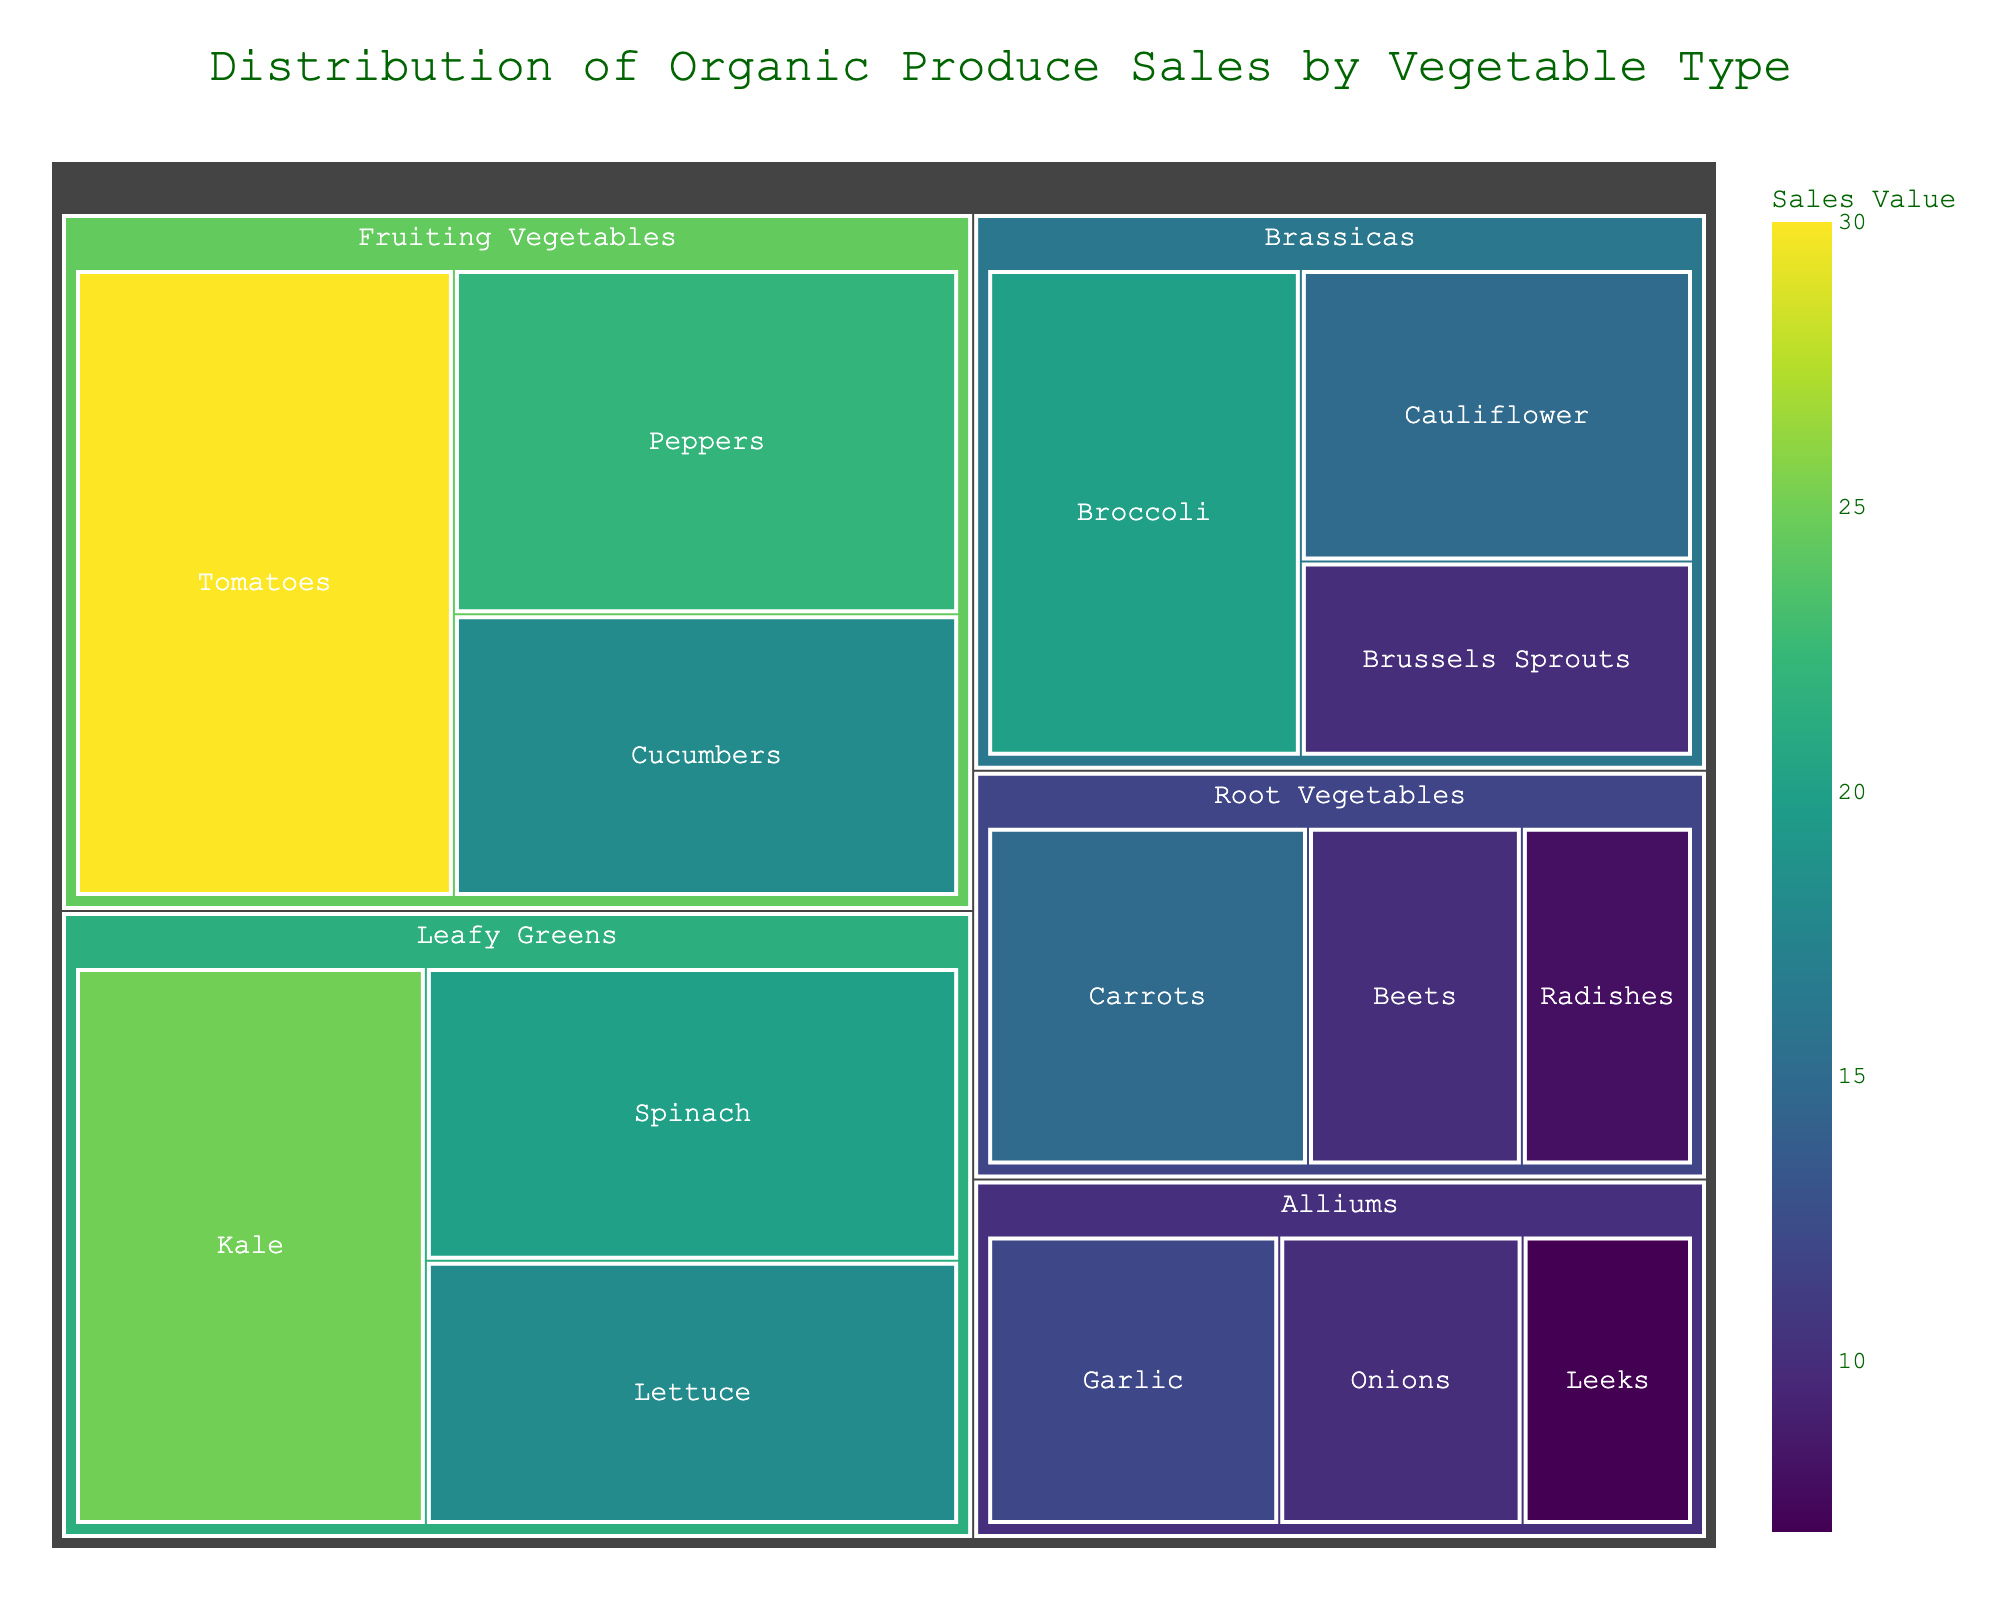How many categories of vegetables are represented in the treemap? The treemap visually shows different vegetable categories. Counting the distinct categories in the plot gives the total.
Answer: 5 Which vegetable subcategory has the highest sales value? The treemap uses color intensity to represent sales values. The subcategory with the most intense color has the highest sales.
Answer: Tomatoes What is the total sales value for the 'Leafy Greens' category? The 'Leafy Greens' category includes Kale, Spinach, and Lettuce with values of 25, 20, and 18, respectively. Summing these values gives 25 + 20 + 18.
Answer: 63 Which category has the lowest total sales value, and what is it? Add the values of subcategories within each category. 'Alliums' has Garlic (12), Onions (10), and Leeks (7), summing up to 29, which is the lowest among all categories.
Answer: Alliums, 29 Compare the sales values of 'Broccoli' and 'Cauliflower'. Which one is higher? The treemap shows Broccoli with a value of 20 and Cauliflower with 15. Comparing these values, Broccoli has a higher value.
Answer: Broccoli What is the average sales value of the 'Fruiting Vegetables' subcategories? The 'Fruiting Vegetables' include Tomatoes (30), Peppers (22), and Cucumbers (18). Calculating the average: (30 + 22 + 18) / 3.
Answer: 23.33 By how much does the sales value of 'Tomatoes' exceed 'Carrots'? The treemap shows Tomatoes with a value of 30 and Carrots with 15. Subtracting these values gives the difference 30 - 15.
Answer: 15 Which subcategory in the 'Root Vegetables' category has the lowest sales value, and what is it? Within 'Root Vegetables', comparing Carrots (15), Beets (10), and Radishes (8), Radishes have the lowest value.
Answer: Radishes, 8 What percentage of 'Leafy Greens' sales is attributed to 'Spinach'? Total sales for 'Leafy Greens' is 63. Spinach's value is 20. The percentage is calculated as (20 / 63) * 100.
Answer: 31.75% Identify the two subcategories with the closest sales values and specify their values. Comparing the sales values of all subcategories, 'Cauliflower' (15) and 'Carrots' (15) have the closest values, both equal.
Answer: Cauliflower and Carrots, 15 